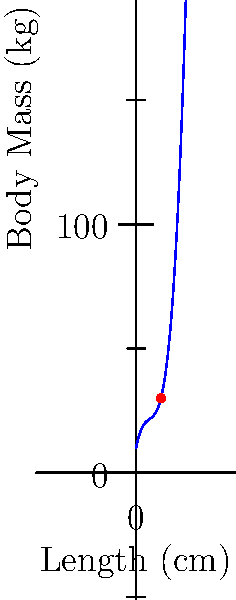As a wildlife veterinarian, you're studying the relationship between body length and mass in a particular species of big cat. You've developed a polynomial regression model to estimate body mass based on length. The model is given by the equation:

$M = 0.05L^3 - 0.8L^2 + 5L + 10$

Where $M$ is the body mass in kilograms and $L$ is the body length in centimeters. Using this model, estimate the body mass of a big cat with a length of 15 cm. To estimate the body mass of the big cat, we need to substitute $L = 15$ into the given polynomial equation:

$M = 0.05L^3 - 0.8L^2 + 5L + 10$

Step 1: Substitute $L = 15$
$M = 0.05(15)^3 - 0.8(15)^2 + 5(15) + 10$

Step 2: Calculate the powers
$M = 0.05(3375) - 0.8(225) + 5(15) + 10$

Step 3: Multiply
$M = 168.75 - 180 + 75 + 10$

Step 4: Add the terms
$M = 73.75$

Therefore, the estimated body mass of a big cat with a length of 15 cm is 73.75 kg.
Answer: 73.75 kg 